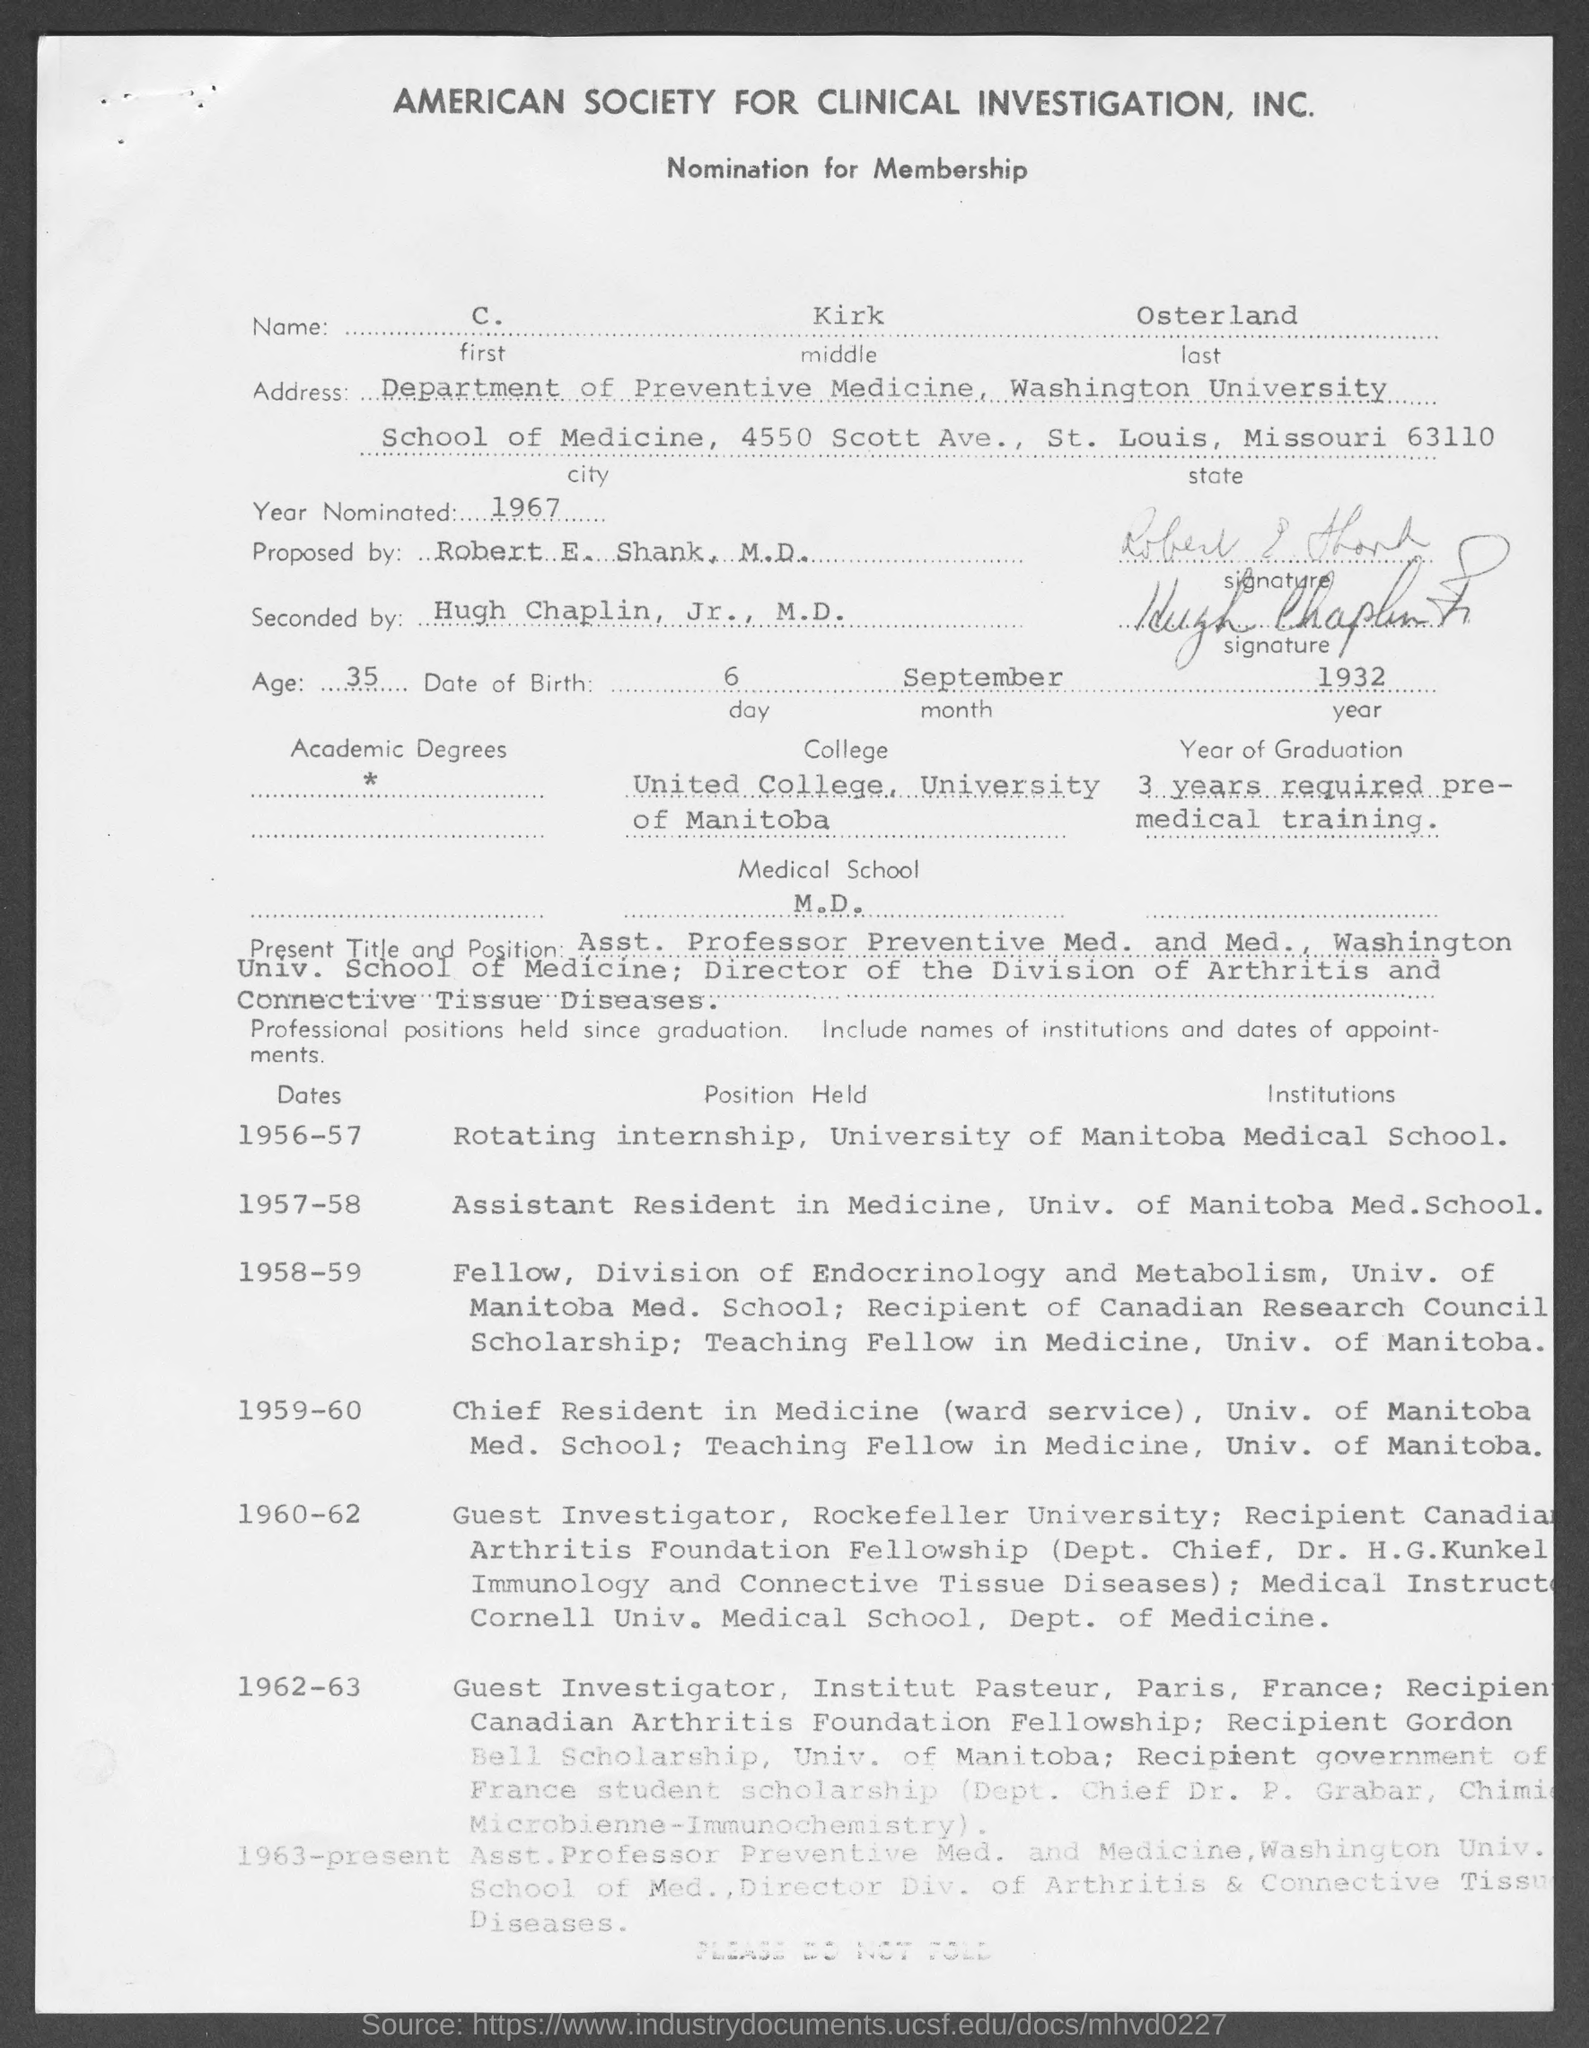Give some essential details in this illustration. The month mentioned in the date of birth in the given form is September. The proposal was made by Robert E. Shank, M.D., as mentioned in the given form. The year mentioned in the date of birth in the given format is 1932. What is the first name mentioned in the given form? It is Clara. The middle name mentioned in the given form is Kirk. 